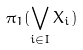Convert formula to latex. <formula><loc_0><loc_0><loc_500><loc_500>\pi _ { 1 } ( \bigvee _ { i \in I } X _ { i } )</formula> 